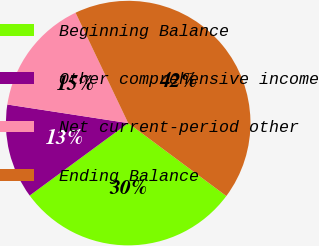Convert chart to OTSL. <chart><loc_0><loc_0><loc_500><loc_500><pie_chart><fcel>Beginning Balance<fcel>Other comprehensive income<fcel>Net current-period other<fcel>Ending Balance<nl><fcel>29.73%<fcel>12.52%<fcel>15.49%<fcel>42.25%<nl></chart> 